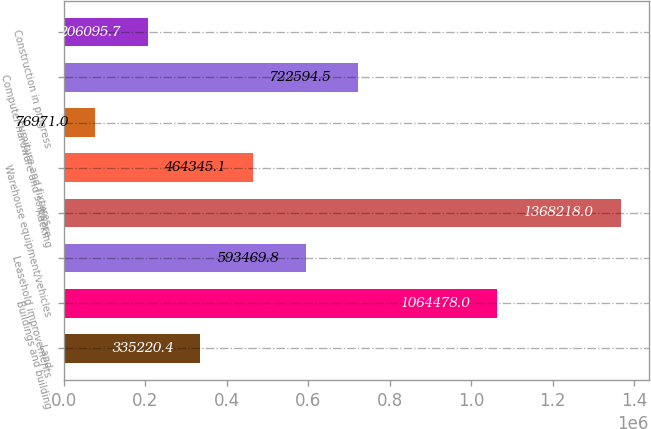Convert chart to OTSL. <chart><loc_0><loc_0><loc_500><loc_500><bar_chart><fcel>Land<fcel>Buildings and building<fcel>Leasehold improvements<fcel>Racking<fcel>Warehouse equipment/vehicles<fcel>Furniture and fixtures<fcel>Computer hardware and software<fcel>Construction in progress<nl><fcel>335220<fcel>1.06448e+06<fcel>593470<fcel>1.36822e+06<fcel>464345<fcel>76971<fcel>722594<fcel>206096<nl></chart> 